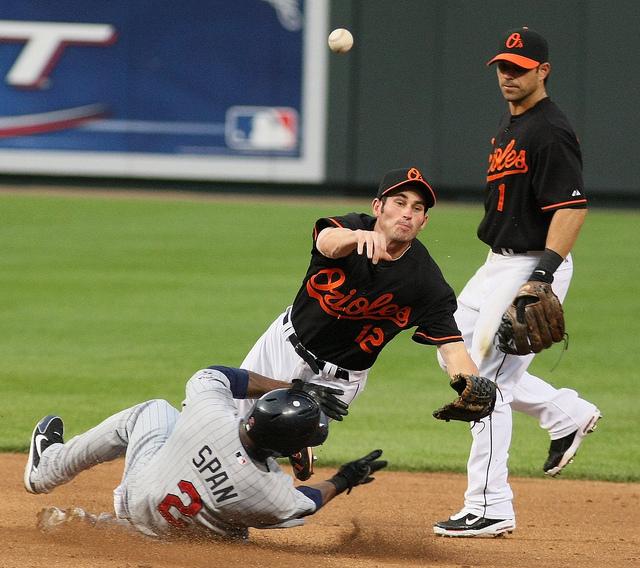Are all of the men's uniforms clean?
Give a very brief answer. No. Why is the guy in white almost on his knees?
Quick response, please. Falling. What is the team name for the man who is sliding?
Be succinct. Orioles. Are both players on the ground?
Quick response, please. No. To what player is the ball traveling to?
Write a very short answer. Catcher. What position does he play?
Concise answer only. Baseman. Where is home plate?
Write a very short answer. None. What number is the player sliding?
Quick response, please. 2. Which person is most likely to catch the ball?
Short answer required. Catcher. Did the runner slide?
Answer briefly. Yes. What team does the man play for?
Quick response, please. Orioles. Will the boy catch the ball?
Give a very brief answer. No. Is the player safe?
Write a very short answer. Yes. If you add the two numbers on the Jersey together, what is the total?
Quick response, please. 3. Was the runner safe?
Quick response, please. Yes. 